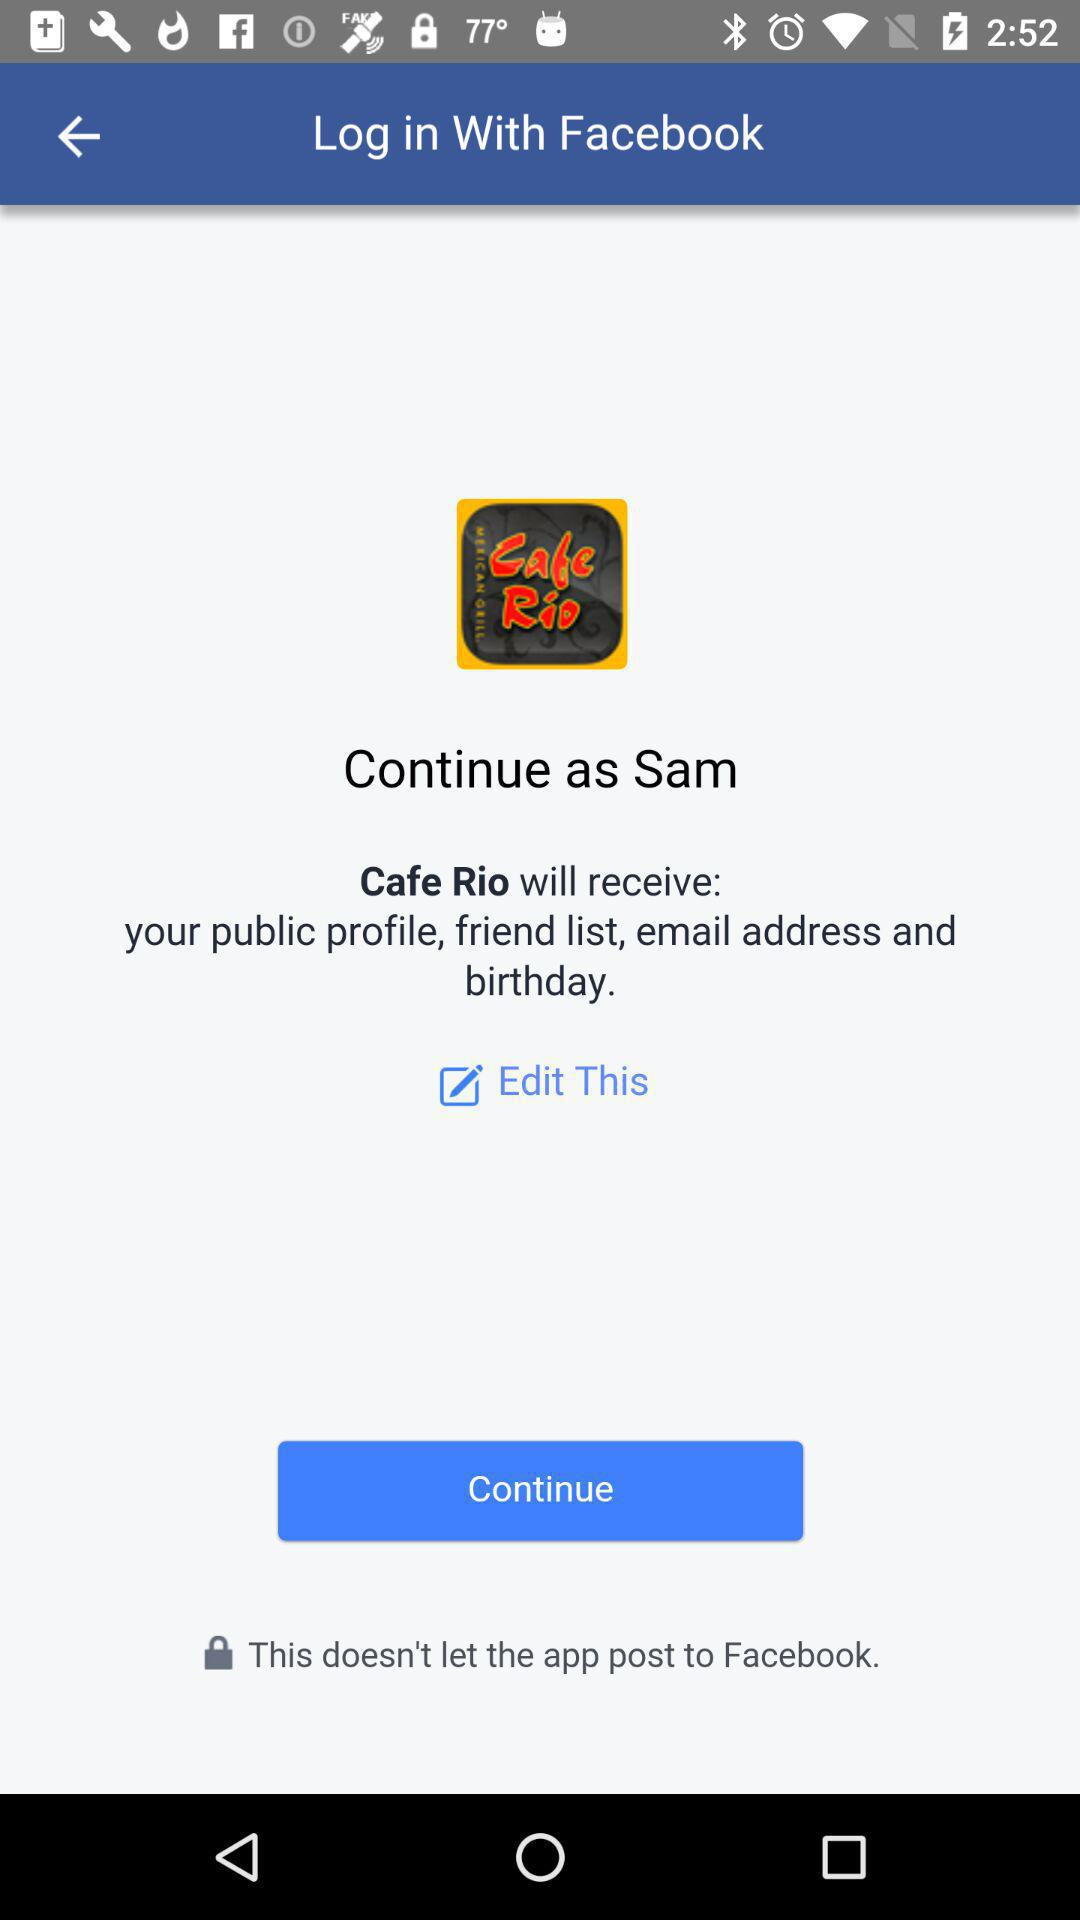What application will receive a public profile, friend list, email address and birthday? The application is "Cafe Rio". 